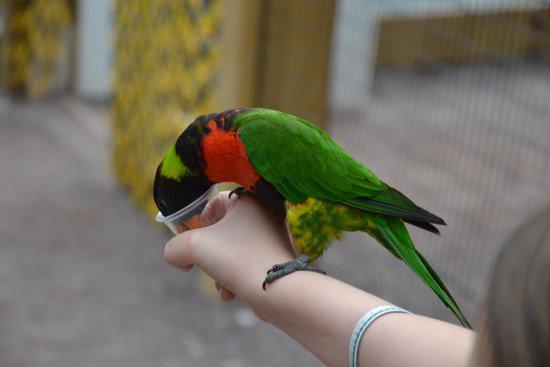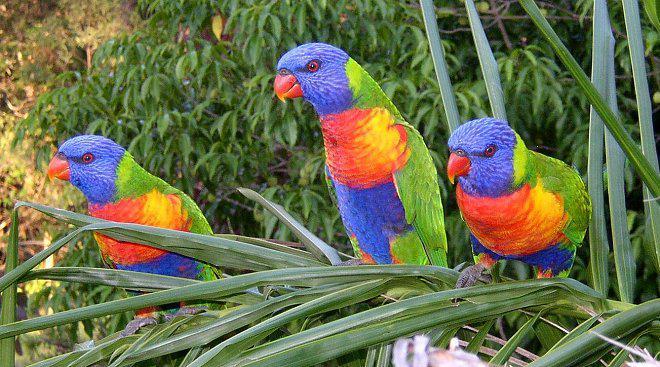The first image is the image on the left, the second image is the image on the right. Evaluate the accuracy of this statement regarding the images: "One image contains at least three similarly colored parrots.". Is it true? Answer yes or no. Yes. 